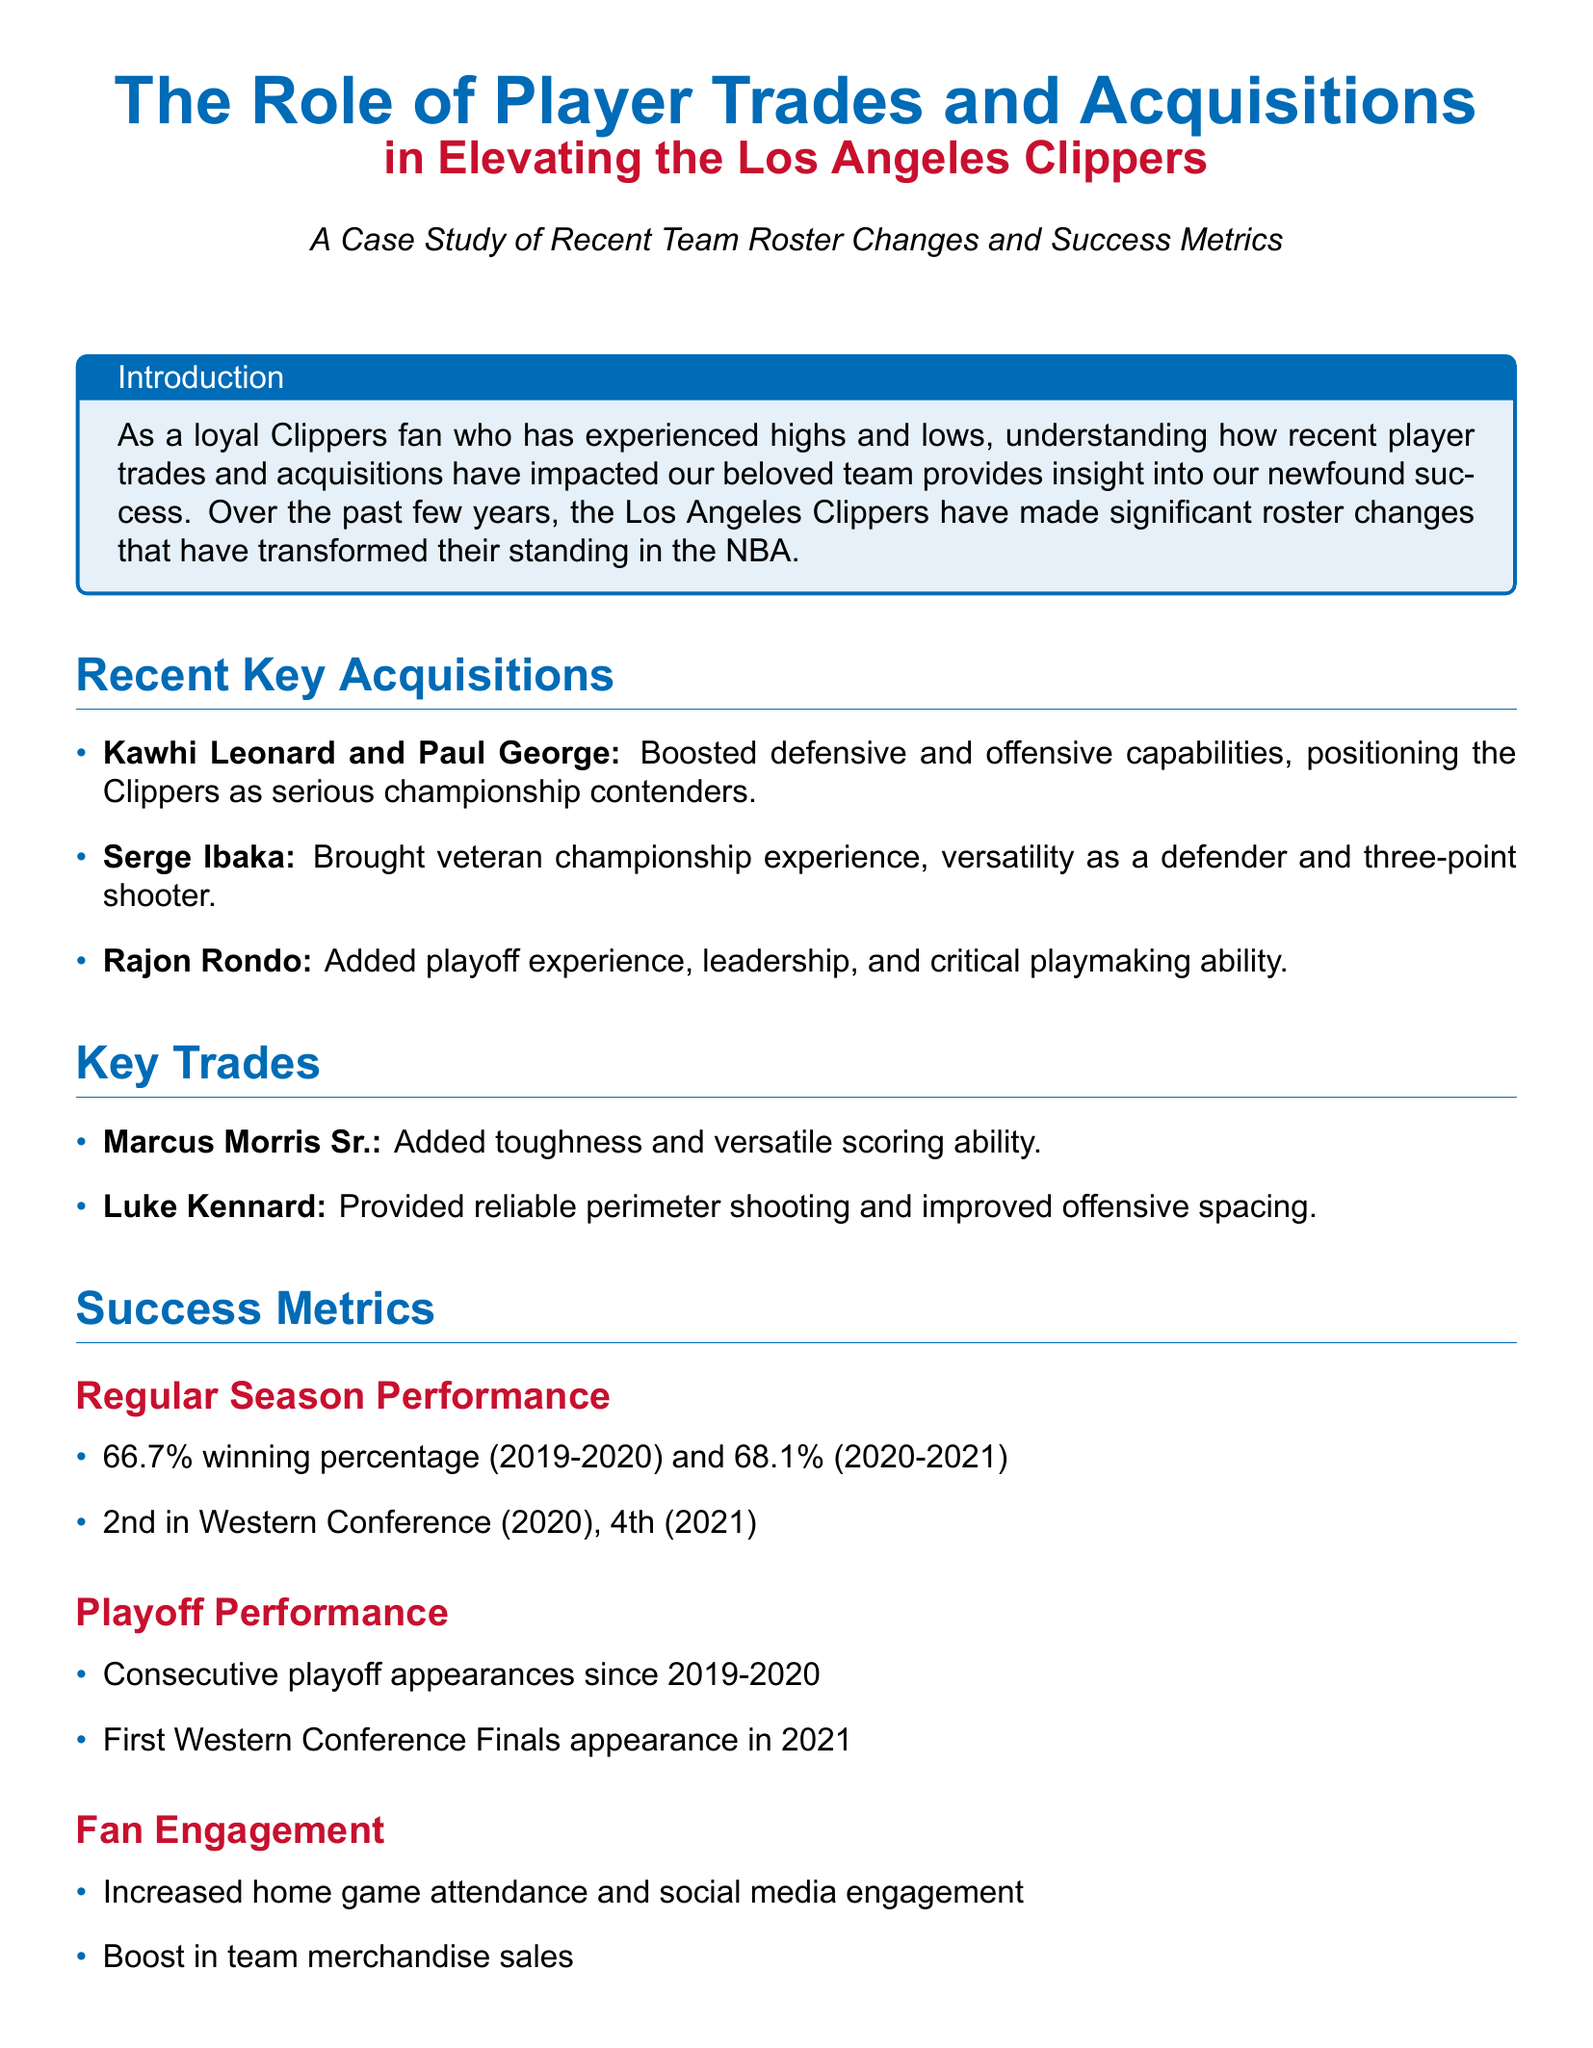what percentage of winning did the Clippers achieve in the regular season 2019-2020? The winning percentage for the regular season 2019-2020 is stated in the success metrics section as 66.7%.
Answer: 66.7% who were the two key players acquired to boost the Clippers’ capabilities? The key acquisitions mentioned in the document are Kawhi Leonard and Paul George.
Answer: Kawhi Leonard and Paul George which player brought veteran championship experience to the Clippers? The document specifies that Serge Ibaka brought veteran championship experience.
Answer: Serge Ibaka what was the Clippers' playoff performance achievement in 2021? The document notes that the Clippers made their first Western Conference Finals appearance in 2021.
Answer: First Western Conference Finals appearance how many consecutive playoff appearances have the Clippers made since 2019-2020? The document indicates that the Clippers have had consecutive playoff appearances since the 2019-2020 season, which quantifies as three seasons now.
Answer: Since 2019-2020 what percentage of winning did the Clippers achieve in the regular season 2020-2021? The winning percentage for the regular season 2020-2021 is mentioned as 68.1%.
Answer: 68.1% which acquisition is noted for adding critical playmaking ability? The document identifies Rajon Rondo as the acquisition that added critical playmaking ability.
Answer: Rajon Rondo what increased engagement metrics are mentioned in the document? The document refers to increased home game attendance and social media engagement as metrics of fan engagement.
Answer: Home game attendance and social media engagement who added toughness and versatile scoring ability to the Clippers? The player noted for adding toughness and versatile scoring ability is Marcus Morris Sr.
Answer: Marcus Morris Sr 